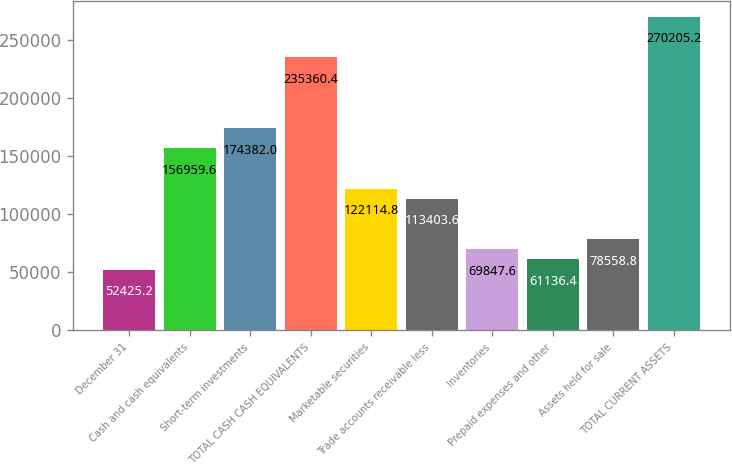Convert chart to OTSL. <chart><loc_0><loc_0><loc_500><loc_500><bar_chart><fcel>December 31<fcel>Cash and cash equivalents<fcel>Short-term investments<fcel>TOTAL CASH CASH EQUIVALENTS<fcel>Marketable securities<fcel>Trade accounts receivable less<fcel>Inventories<fcel>Prepaid expenses and other<fcel>Assets held for sale<fcel>TOTAL CURRENT ASSETS<nl><fcel>52425.2<fcel>156960<fcel>174382<fcel>235360<fcel>122115<fcel>113404<fcel>69847.6<fcel>61136.4<fcel>78558.8<fcel>270205<nl></chart> 